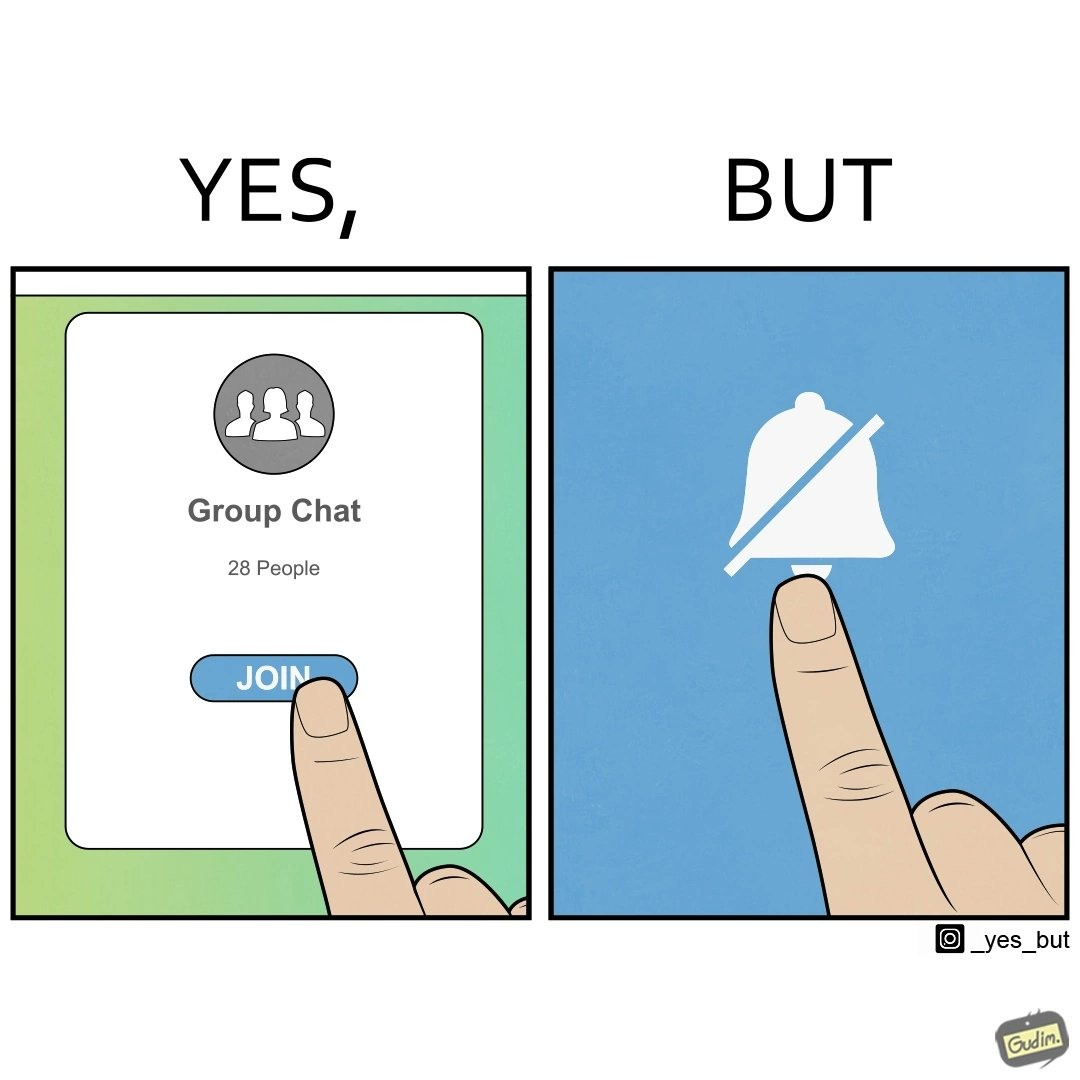Why is this image considered satirical? This is ironic because the person joining the big social group, presumably interested in the happenings of that group, motivated to engage with these people, MUTEs the group as soon as they join it, indicating they are not interested in it and do not  want to be bothered by it.  These actions are contradictory from a social perspective, and illuminate a weird fact about present day online life. 